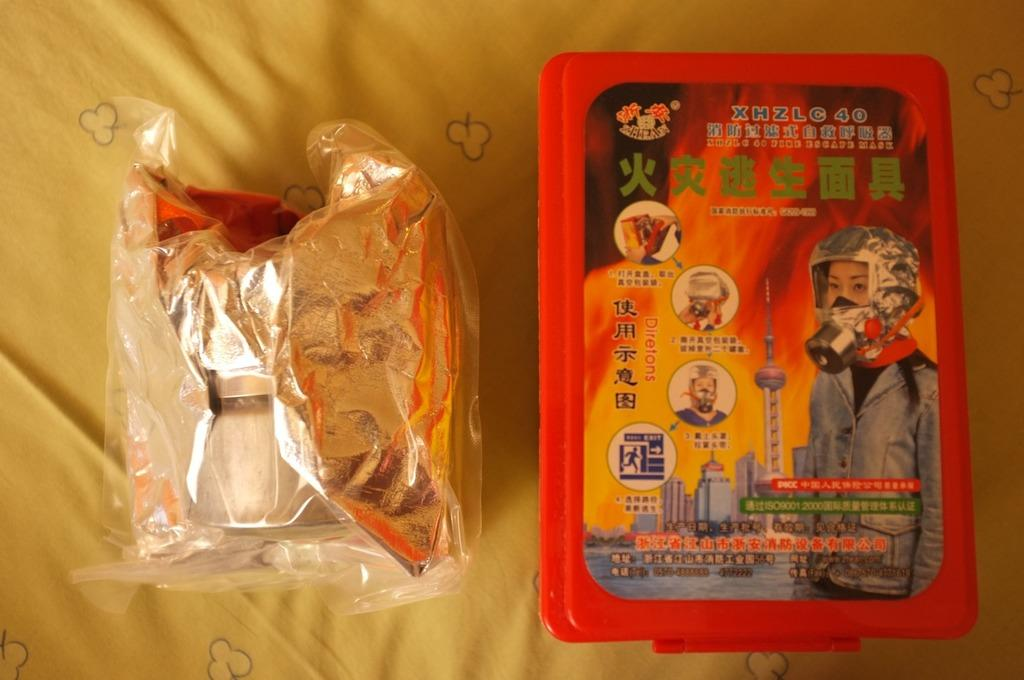What color is the cloth that is visible in the image? The cloth in the image is yellow-colored. What else can be seen in the image besides the yellow cloth? There are packets with objects and a red-colored box in the image. What is the color of the box in the image? The box in the image is red-colored. What is featured on the red-colored box? The red-colored box has an advertisement on it. What is the route to the airport from the location of the yellow cloth in the image? There is no information about the location or the route to the airport in the image. How many people are taking a bath in the image? There is no indication of a bath or any people in the image. 